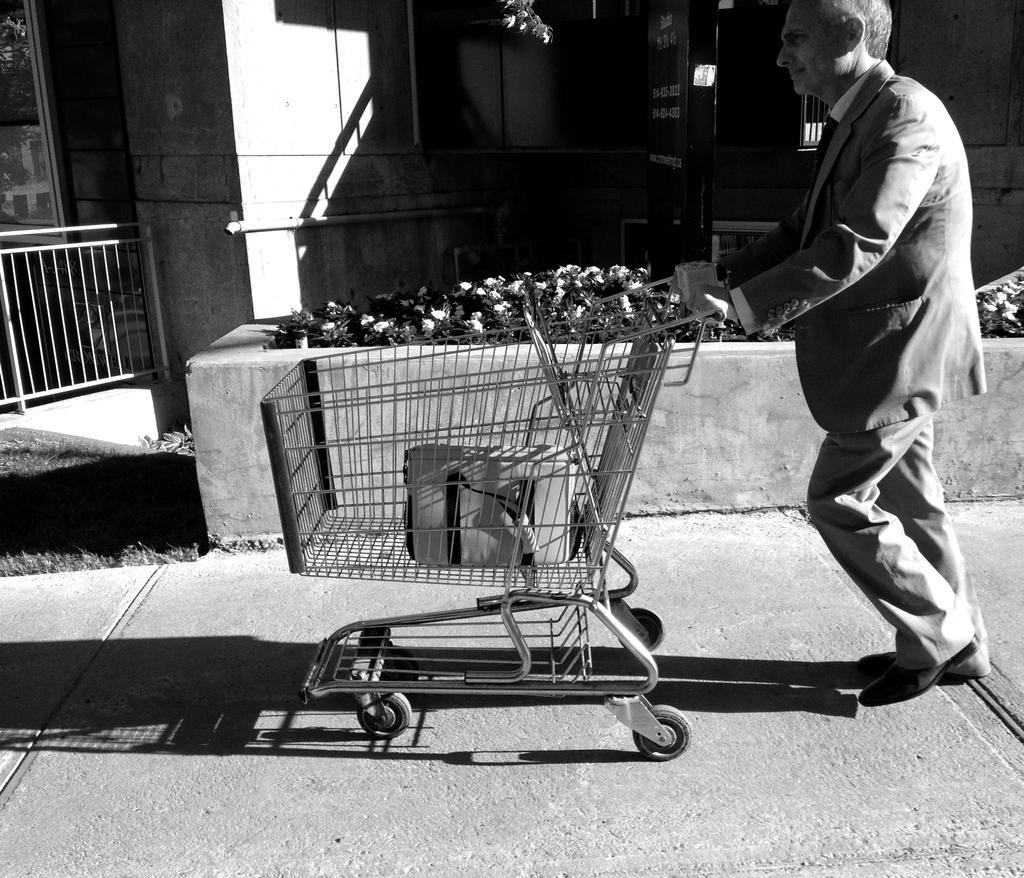Describe this image in one or two sentences. This is a black and white picture. In this picture, we see a man in the blazer is holding a shopping trolley in his hands and he is walking. We see a bag is placed in the trolley. At the bottom, we see the road. Beside him, we see the shrubs and the plants which have flowers. On the left side, we see a pole, railing and the grass. In the background, we see a building and a board in black color with some text written on it. 